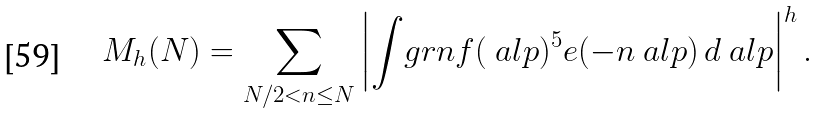Convert formula to latex. <formula><loc_0><loc_0><loc_500><loc_500>M _ { h } ( N ) = \sum _ { N / 2 < n \leq N } \left | \int _ { \ } g r n f ( \ a l p ) ^ { 5 } e ( - n \ a l p ) \, d \ a l p \right | ^ { h } .</formula> 